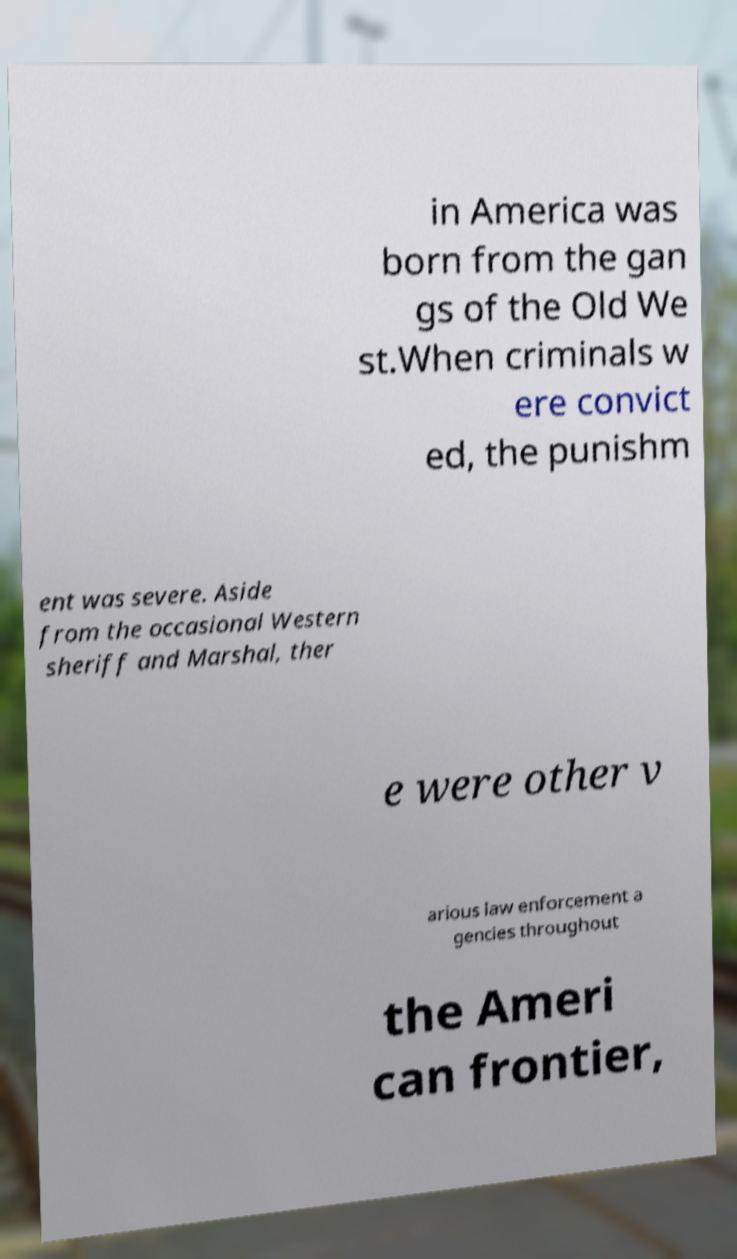I need the written content from this picture converted into text. Can you do that? in America was born from the gan gs of the Old We st.When criminals w ere convict ed, the punishm ent was severe. Aside from the occasional Western sheriff and Marshal, ther e were other v arious law enforcement a gencies throughout the Ameri can frontier, 